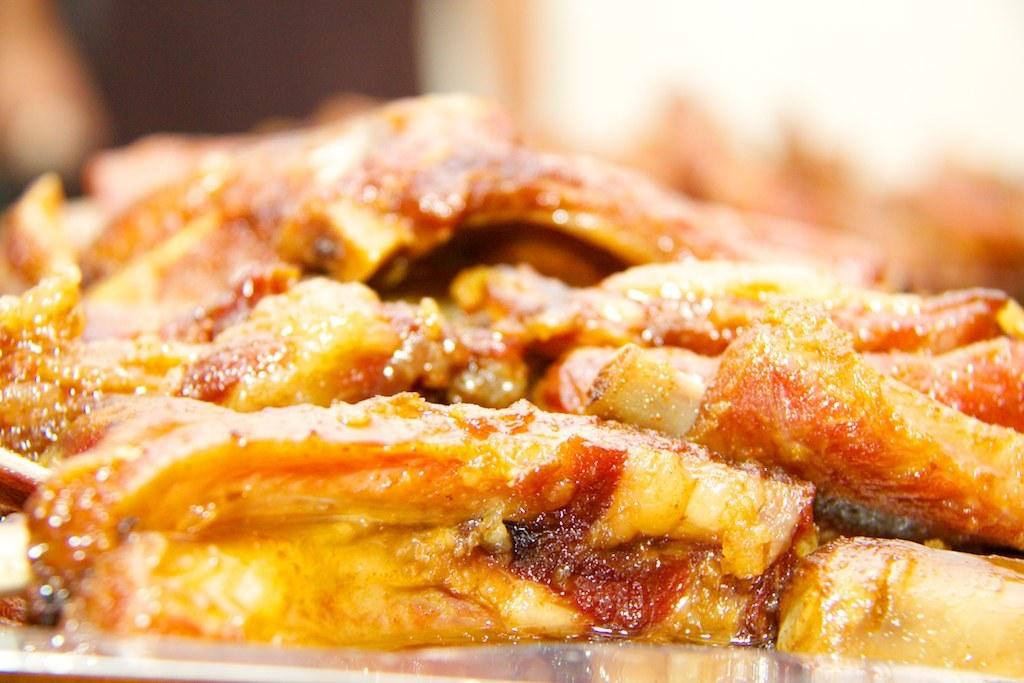What can be seen in the image? There are food items visible in the image. Can you describe the background of the image? The background of the image is blurred. What type of songs can be heard coming from the hands in the image? There are no hands or songs present in the image. 